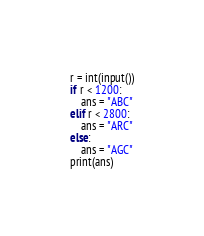Convert code to text. <code><loc_0><loc_0><loc_500><loc_500><_Python_>r = int(input())
if r < 1200:
    ans = "ABC"
elif r < 2800:
    ans = "ARC"
else:
    ans = "AGC"
print(ans)</code> 